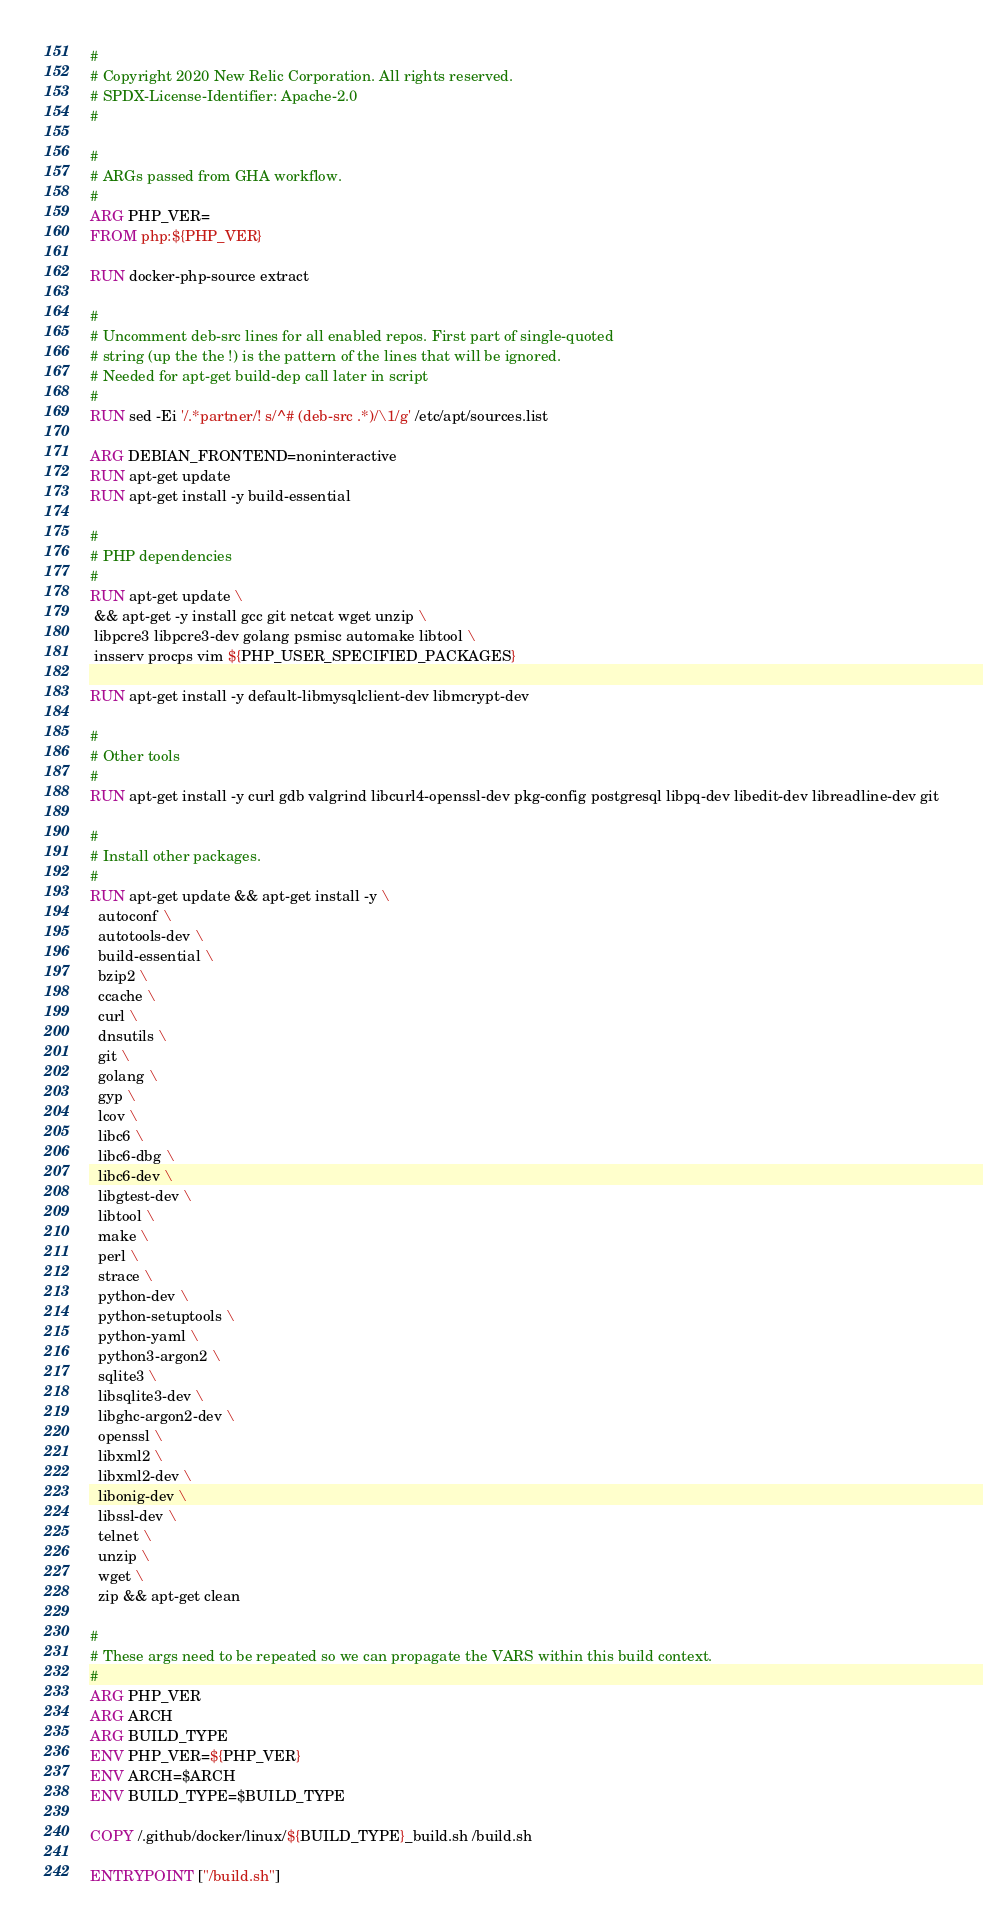Convert code to text. <code><loc_0><loc_0><loc_500><loc_500><_Dockerfile_>#
# Copyright 2020 New Relic Corporation. All rights reserved.
# SPDX-License-Identifier: Apache-2.0
#

#
# ARGs passed from GHA workflow.
#
ARG PHP_VER=
FROM php:${PHP_VER}

RUN docker-php-source extract

#
# Uncomment deb-src lines for all enabled repos. First part of single-quoted
# string (up the the !) is the pattern of the lines that will be ignored.
# Needed for apt-get build-dep call later in script
#
RUN sed -Ei '/.*partner/! s/^# (deb-src .*)/\1/g' /etc/apt/sources.list

ARG DEBIAN_FRONTEND=noninteractive
RUN apt-get update
RUN apt-get install -y build-essential

#
# PHP dependencies
#
RUN apt-get update \
 && apt-get -y install gcc git netcat wget unzip \
 libpcre3 libpcre3-dev golang psmisc automake libtool \
 insserv procps vim ${PHP_USER_SPECIFIED_PACKAGES}

RUN apt-get install -y default-libmysqlclient-dev libmcrypt-dev

#
# Other tools
#
RUN apt-get install -y curl gdb valgrind libcurl4-openssl-dev pkg-config postgresql libpq-dev libedit-dev libreadline-dev git

#
# Install other packages.
#
RUN apt-get update && apt-get install -y \
  autoconf \
  autotools-dev \
  build-essential \
  bzip2 \
  ccache \
  curl \
  dnsutils \
  git \
  golang \
  gyp \
  lcov \
  libc6 \
  libc6-dbg \
  libc6-dev \
  libgtest-dev \
  libtool \
  make \
  perl \
  strace \
  python-dev \
  python-setuptools \
  python-yaml \
  python3-argon2 \
  sqlite3 \
  libsqlite3-dev \
  libghc-argon2-dev \
  openssl \
  libxml2 \
  libxml2-dev \
  libonig-dev \
  libssl-dev \
  telnet \
  unzip \
  wget \
  zip && apt-get clean

#
# These args need to be repeated so we can propagate the VARS within this build context.
#
ARG PHP_VER
ARG ARCH
ARG BUILD_TYPE
ENV PHP_VER=${PHP_VER}
ENV ARCH=$ARCH
ENV BUILD_TYPE=$BUILD_TYPE

COPY /.github/docker/linux/${BUILD_TYPE}_build.sh /build.sh

ENTRYPOINT ["/build.sh"]
</code> 